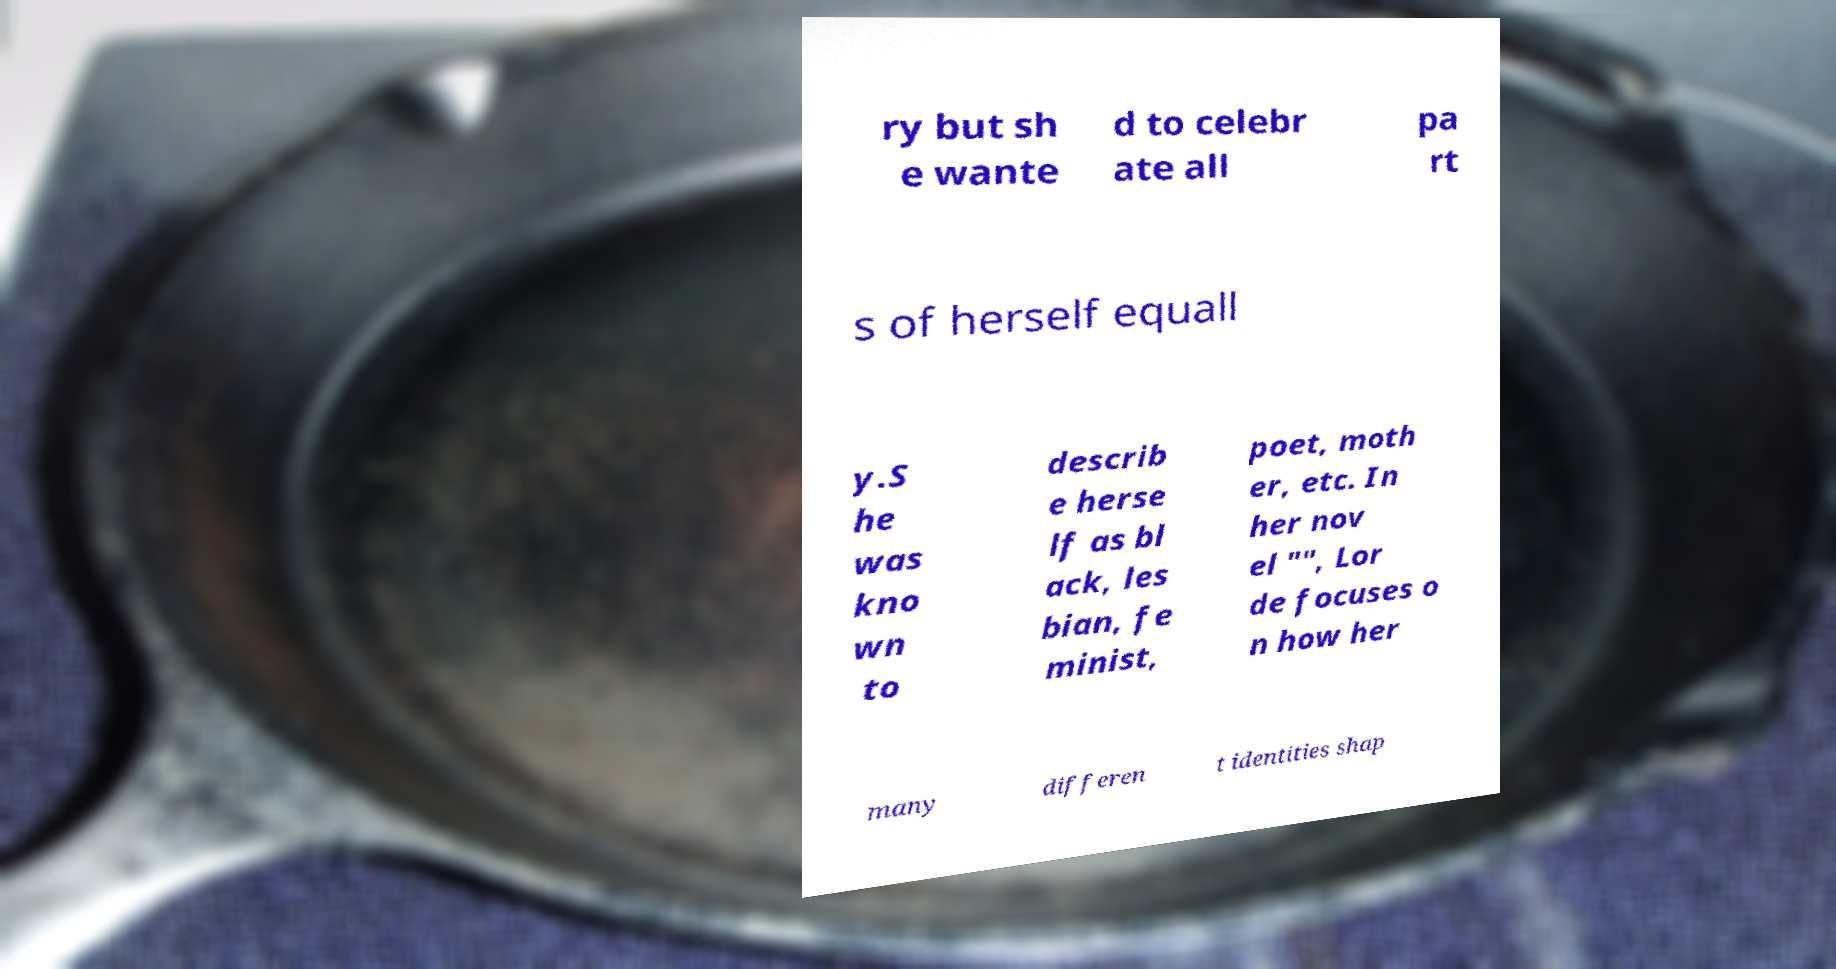I need the written content from this picture converted into text. Can you do that? ry but sh e wante d to celebr ate all pa rt s of herself equall y.S he was kno wn to describ e herse lf as bl ack, les bian, fe minist, poet, moth er, etc. In her nov el "", Lor de focuses o n how her many differen t identities shap 